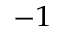<formula> <loc_0><loc_0><loc_500><loc_500>^ { - 1 }</formula> 